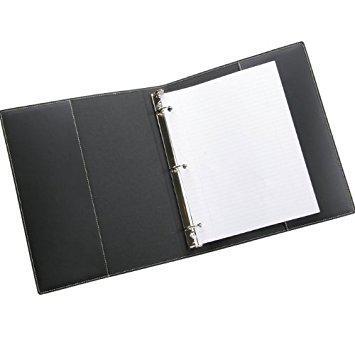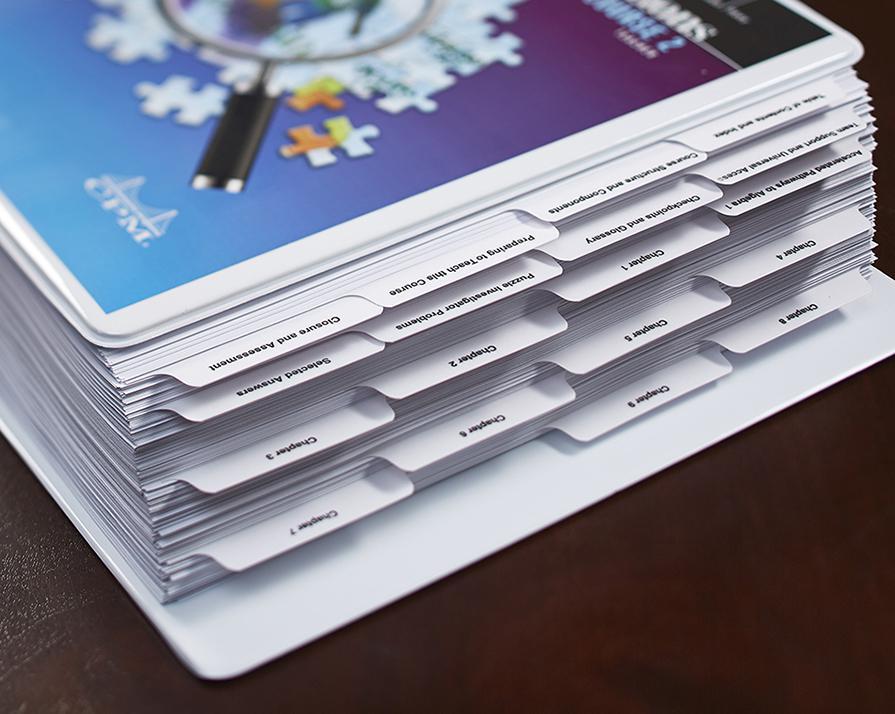The first image is the image on the left, the second image is the image on the right. For the images shown, is this caption "One of the binders is full and has dividers tabs." true? Answer yes or no. Yes. 